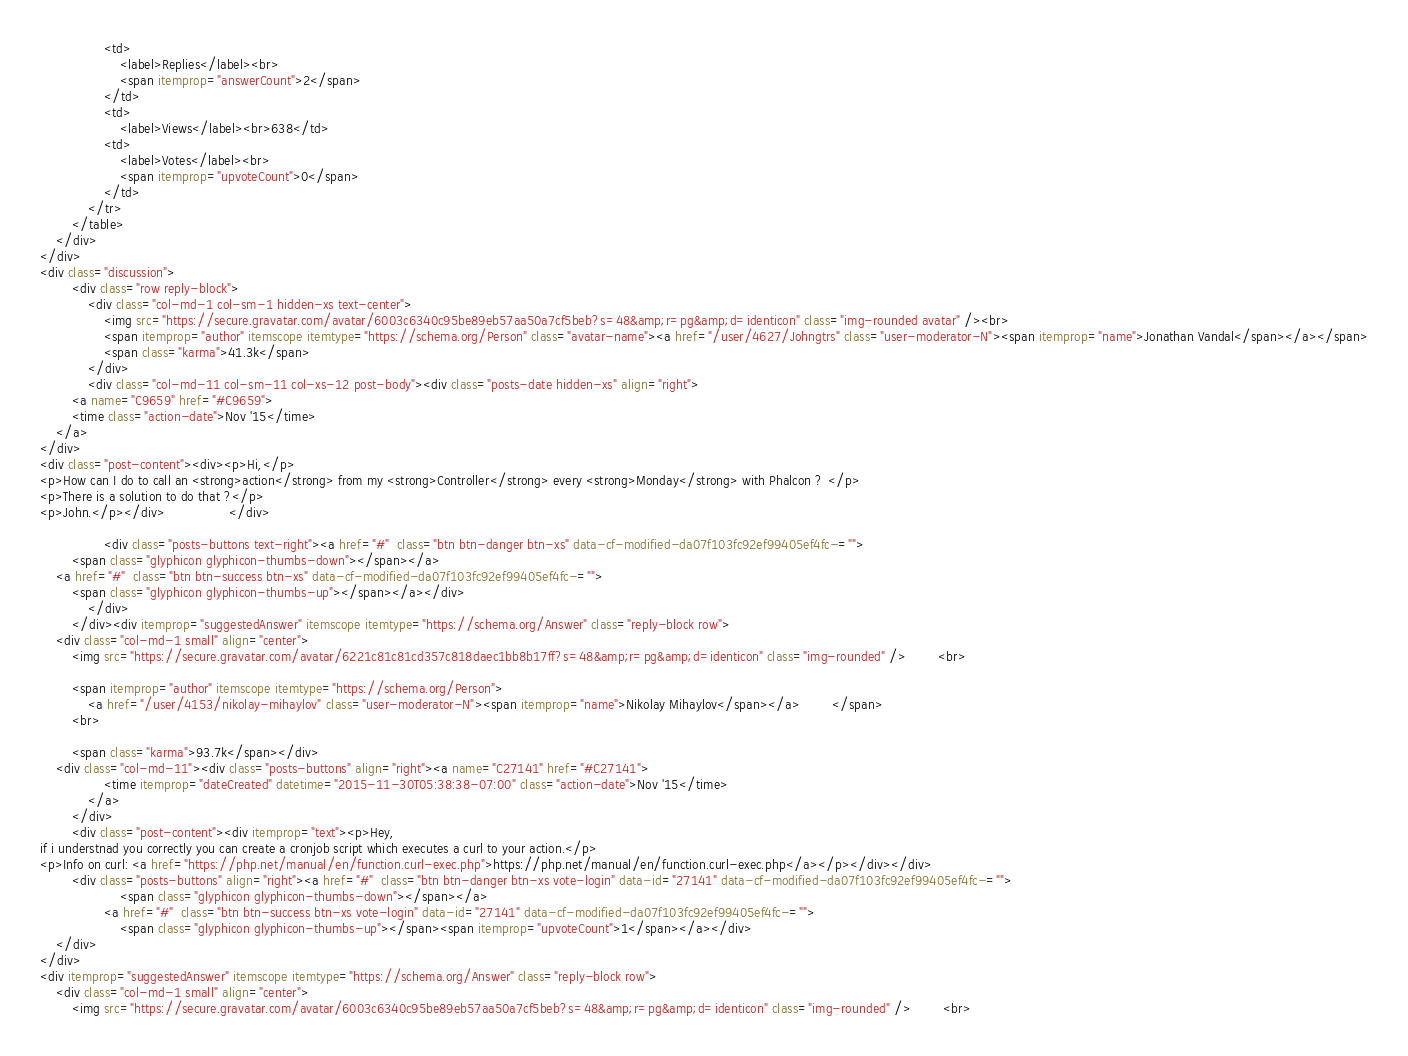Convert code to text. <code><loc_0><loc_0><loc_500><loc_500><_HTML_>                <td>
                    <label>Replies</label><br>
                    <span itemprop="answerCount">2</span>
                </td>
                <td>
                    <label>Views</label><br>638</td>
                <td>
                    <label>Votes</label><br>
                    <span itemprop="upvoteCount">0</span>
                </td>
            </tr>
        </table>
    </div>
</div>
<div class="discussion">
        <div class="row reply-block">
            <div class="col-md-1 col-sm-1 hidden-xs text-center">
                <img src="https://secure.gravatar.com/avatar/6003c6340c95be89eb57aa50a7cf5beb?s=48&amp;r=pg&amp;d=identicon" class="img-rounded avatar" /><br>
                <span itemprop="author" itemscope itemtype="https://schema.org/Person" class="avatar-name"><a href="/user/4627/Johngtrs" class="user-moderator-N"><span itemprop="name">Jonathan Vandal</span></a></span>
                <span class="karma">41.3k</span>
            </div>
            <div class="col-md-11 col-sm-11 col-xs-12 post-body"><div class="posts-date hidden-xs" align="right">
        <a name="C9659" href="#C9659">
        <time class="action-date">Nov '15</time>
    </a>
</div>
<div class="post-content"><div><p>Hi,</p>
<p>How can I do to call an <strong>action</strong> from my <strong>Controller</strong> every <strong>Monday</strong> with Phalcon ? </p>
<p>There is a solution to do that ?</p>
<p>John.</p></div>                </div>

                <div class="posts-buttons text-right"><a href="#"  class="btn btn-danger btn-xs" data-cf-modified-da07f103fc92ef99405ef4fc-="">
        <span class="glyphicon glyphicon-thumbs-down"></span></a>
    <a href="#"  class="btn btn-success btn-xs" data-cf-modified-da07f103fc92ef99405ef4fc-="">
        <span class="glyphicon glyphicon-thumbs-up"></span></a></div>
            </div>
        </div><div itemprop="suggestedAnswer" itemscope itemtype="https://schema.org/Answer" class="reply-block row">
    <div class="col-md-1 small" align="center">
        <img src="https://secure.gravatar.com/avatar/6221c81c81cd357c818daec1bb8b17ff?s=48&amp;r=pg&amp;d=identicon" class="img-rounded" />        <br>

        <span itemprop="author" itemscope itemtype="https://schema.org/Person">
            <a href="/user/4153/nikolay-mihaylov" class="user-moderator-N"><span itemprop="name">Nikolay Mihaylov</span></a>        </span>
        <br>

        <span class="karma">93.7k</span></div>
    <div class="col-md-11"><div class="posts-buttons" align="right"><a name="C27141" href="#C27141">
                <time itemprop="dateCreated" datetime="2015-11-30T05:38:38-07:00" class="action-date">Nov '15</time>
            </a>
        </div>
        <div class="post-content"><div itemprop="text"><p>Hey,
if i understnad you correctly you can create a cronjob script which executes a curl to your action.</p>
<p>Info on curl: <a href="https://php.net/manual/en/function.curl-exec.php">https://php.net/manual/en/function.curl-exec.php</a></p></div></div>
        <div class="posts-buttons" align="right"><a href="#"  class="btn btn-danger btn-xs vote-login" data-id="27141" data-cf-modified-da07f103fc92ef99405ef4fc-="">
                    <span class="glyphicon glyphicon-thumbs-down"></span></a>
                <a href="#"  class="btn btn-success btn-xs vote-login" data-id="27141" data-cf-modified-da07f103fc92ef99405ef4fc-="">
                    <span class="glyphicon glyphicon-thumbs-up"></span><span itemprop="upvoteCount">1</span></a></div>
    </div>
</div>
<div itemprop="suggestedAnswer" itemscope itemtype="https://schema.org/Answer" class="reply-block row">
    <div class="col-md-1 small" align="center">
        <img src="https://secure.gravatar.com/avatar/6003c6340c95be89eb57aa50a7cf5beb?s=48&amp;r=pg&amp;d=identicon" class="img-rounded" />        <br>
</code> 